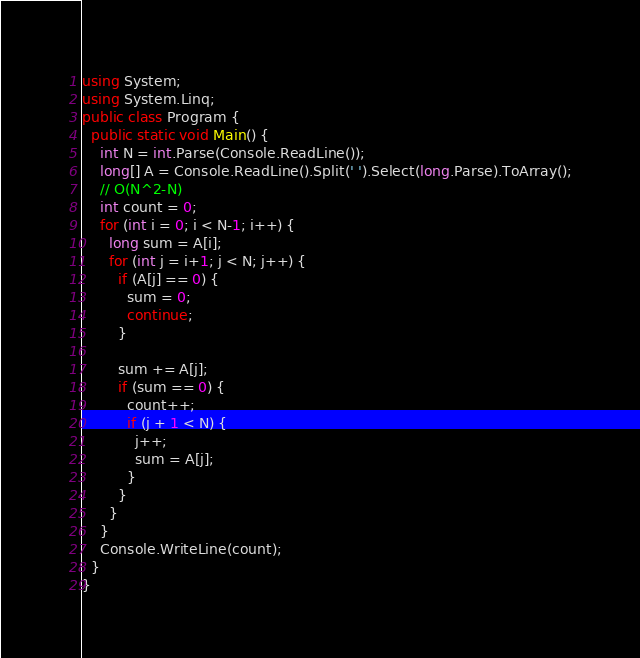<code> <loc_0><loc_0><loc_500><loc_500><_C#_>using System;
using System.Linq;
public class Program {
  public static void Main() {
    int N = int.Parse(Console.ReadLine());
    long[] A = Console.ReadLine().Split(' ').Select(long.Parse).ToArray();
    // O(N^2-N)
    int count = 0;
    for (int i = 0; i < N-1; i++) {
      long sum = A[i];
      for (int j = i+1; j < N; j++) {
        if (A[j] == 0) {
          sum = 0;
          continue;
        }

        sum += A[j];
        if (sum == 0) {
          count++;
          if (j + 1 < N) {
            j++;
            sum = A[j];
          }
        }
      }
    }
    Console.WriteLine(count);
  }
}
</code> 